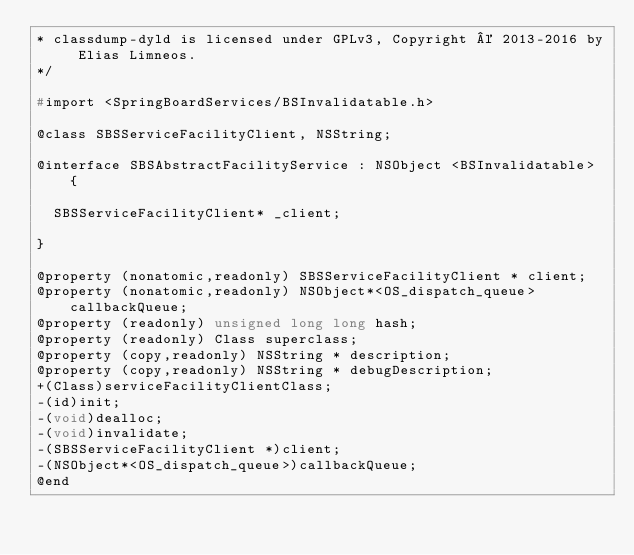<code> <loc_0><loc_0><loc_500><loc_500><_C_>* classdump-dyld is licensed under GPLv3, Copyright © 2013-2016 by Elias Limneos.
*/

#import <SpringBoardServices/BSInvalidatable.h>

@class SBSServiceFacilityClient, NSString;

@interface SBSAbstractFacilityService : NSObject <BSInvalidatable> {

	SBSServiceFacilityClient* _client;

}

@property (nonatomic,readonly) SBSServiceFacilityClient * client; 
@property (nonatomic,readonly) NSObject*<OS_dispatch_queue> callbackQueue; 
@property (readonly) unsigned long long hash; 
@property (readonly) Class superclass; 
@property (copy,readonly) NSString * description; 
@property (copy,readonly) NSString * debugDescription; 
+(Class)serviceFacilityClientClass;
-(id)init;
-(void)dealloc;
-(void)invalidate;
-(SBSServiceFacilityClient *)client;
-(NSObject*<OS_dispatch_queue>)callbackQueue;
@end

</code> 